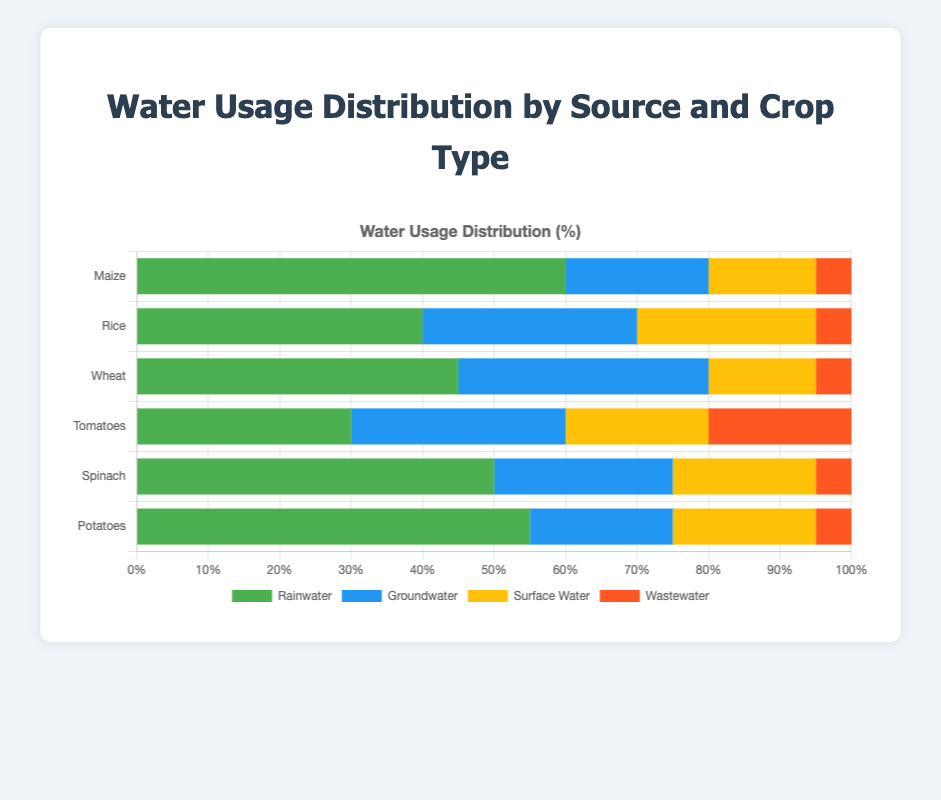What crop relies most on rainwater? The figure shows layered bars where rainwater usage is indicated by the green portion. By observing, Maize has the highest rainwater usage at 60%.
Answer: Maize Which crop has the least use of groundwater? Groundwater usage is shown in blue in the bars. Maize and Potatoes both have the lowest groundwater usage at 20%.
Answer: Maize and Potatoes How much more surface water does Rice use compared to Spinach? Surface water usage is shown in yellow. Rice uses 25% surface water, and Spinach uses 20%. The difference is 25% - 20% = 5%.
Answer: 5% What is the average rainwater usage across all crops? Summing up the rainwater percentages: 60 + 40 + 45 + 30 + 50 + 55 = 280. There are 6 crops, so the average is 280/6 ≈ 46.67%.
Answer: 46.67% Which crop has the highest percentage of wastewater usage, and what is that percentage? Wastewater usage is shown in red. Both Tomatoes and Spinach have the highest wastewater usage at 20%.
Answer: Tomatoes and Spinach By looking at the colors, which water source is used the least overall? The least used color segment across all bars is red (Wastewater). By visual estimation, it is evident that wastewater has the smallest segments in all bars.
Answer: Wastewater How much total groundwater is used by Wheat and Tomatoes combined? Groundwater usage is represented in blue. Wheat uses 35% and Tomatoes use 30%. The total is 35% + 30% = 65%.
Answer: 65% Which crop has an equal distribution of rainwater and groundwater usage? The red and blue parts of the bar for Tomatoes are equal at 30% each.
Answer: Tomatoes 